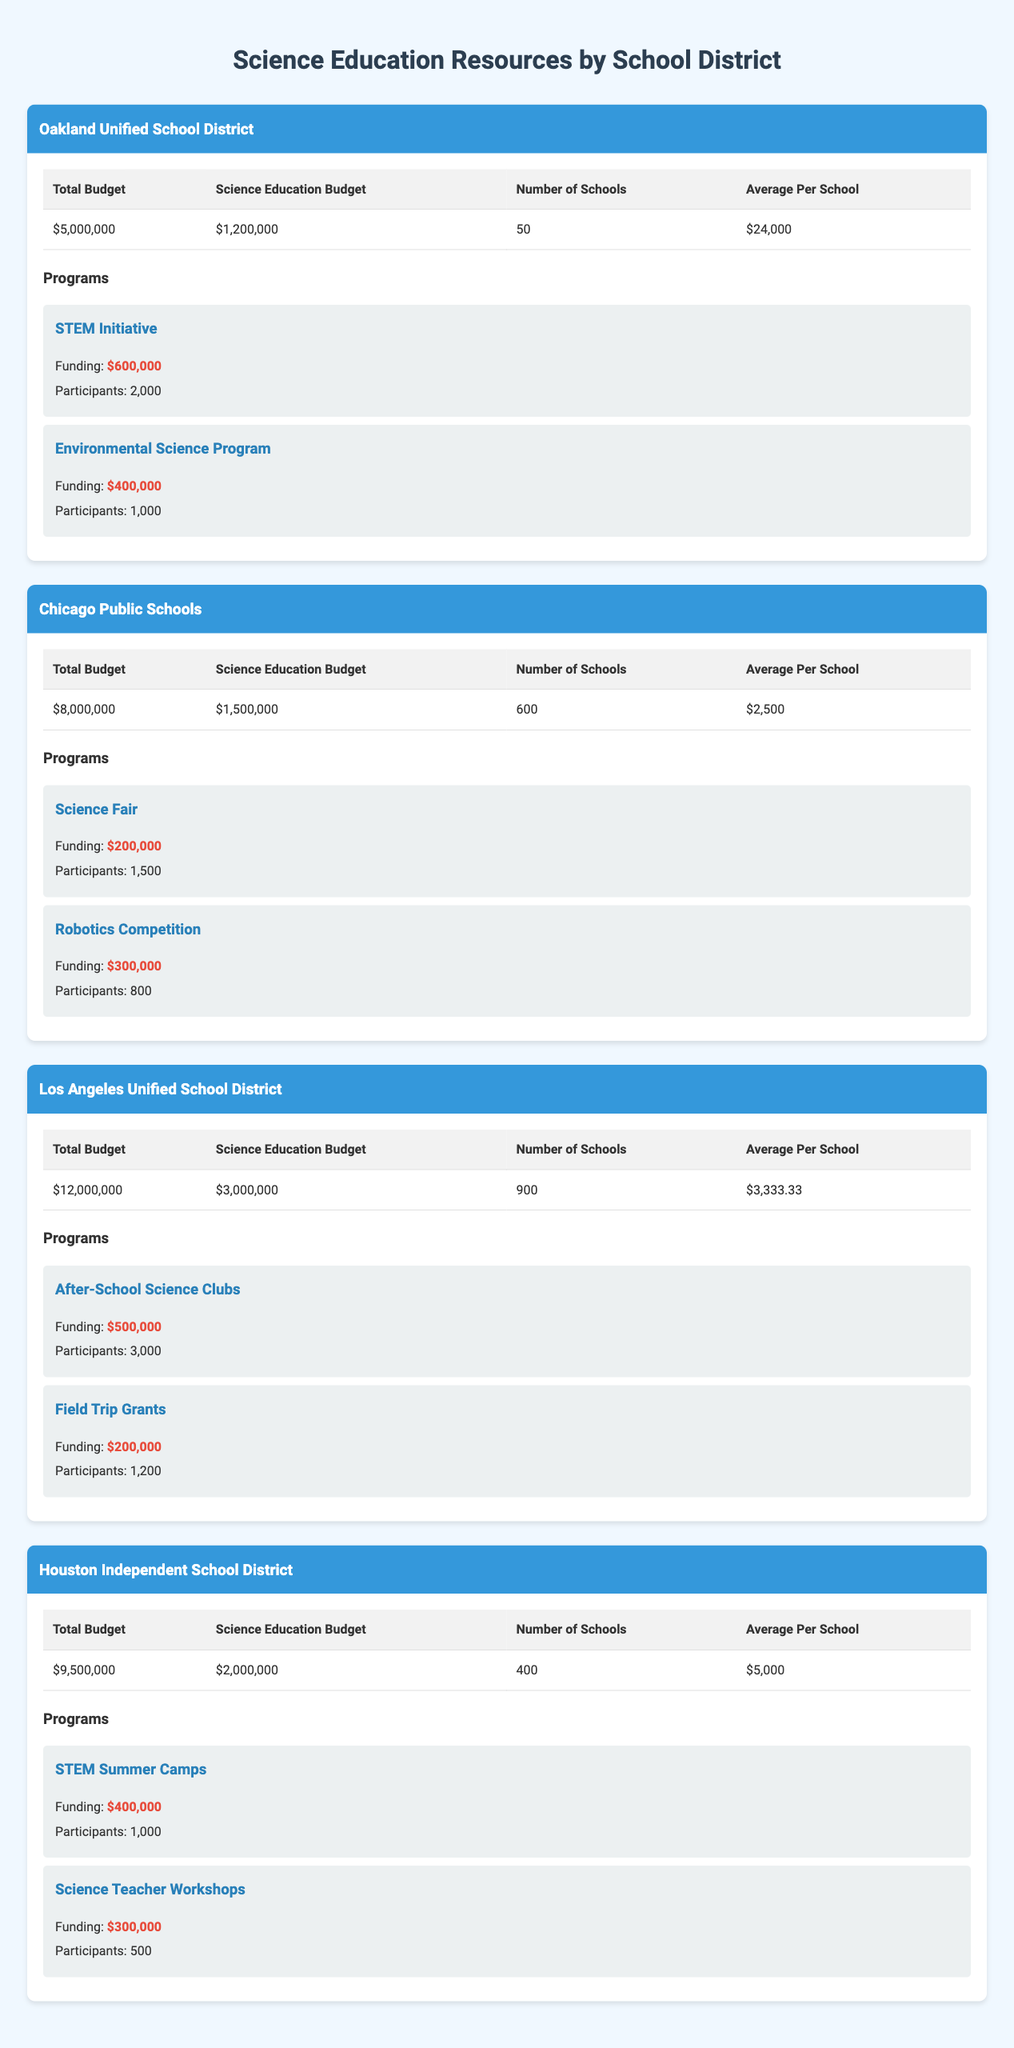What is the total budget for the Chicago Public Schools? The total budget for the Chicago Public Schools is listed in the table under the "Total Budget" column in the row for Chicago Public Schools. It shows $8,000,000.
Answer: $8,000,000 How much is allocated to science education in the Los Angeles Unified School District? The science education budget for the Los Angeles Unified School District can be found in the "Science Education Budget" column for that district. It shows $3,000,000.
Answer: $3,000,000 What is the average amount allocated for science education per school in the Oakland Unified School District? The average amount allocated for science education is in the "Average Per School" column specific to the Oakland Unified School District, which is $24,000.
Answer: $24,000 Which district has the highest science education budget? By comparing the "Science Education Budget" values from each district, we find that the Los Angeles Unified School District has the highest at $3,000,000.
Answer: Los Angeles Unified School District Does the Houston Independent School District have more schools than the Oakland Unified School District? Comparing the "Number of Schools" values reveals that Houston Independent School District has 400 schools, whereas Oakland Unified School District has 50 schools, so it is false.
Answer: No What is the total funding for the STEM-related programs in Oakland Unified School District? The STEM-related programs in Oakland include the "STEM Initiative" and the "Science Teacher Workshops." The total funding is $600,000 (STEM Initiative) + $400,000 (Environmental Science Program) = $1,000,000.
Answer: $1,000,000 How many total participants are there in science education programs in the Los Angeles Unified School District? To find the total participants, add up the participants from each program in the Los Angeles Unified School District: 3,000 (After-School Science Clubs) + 1,200 (Field Trip Grants) = 4,200.
Answer: 4,200 What is the average per school for the Chicago Public Schools? The average per school for Chicago Public Schools can be found in the "Average Per School" column, which is $2,500.
Answer: $2,500 Which district has a total budget higher than $10 million? By checking the "Total Budget" column, we see that only the Los Angeles Unified School District has a total budget of $12,000,000, which is higher than $10 million.
Answer: Yes 